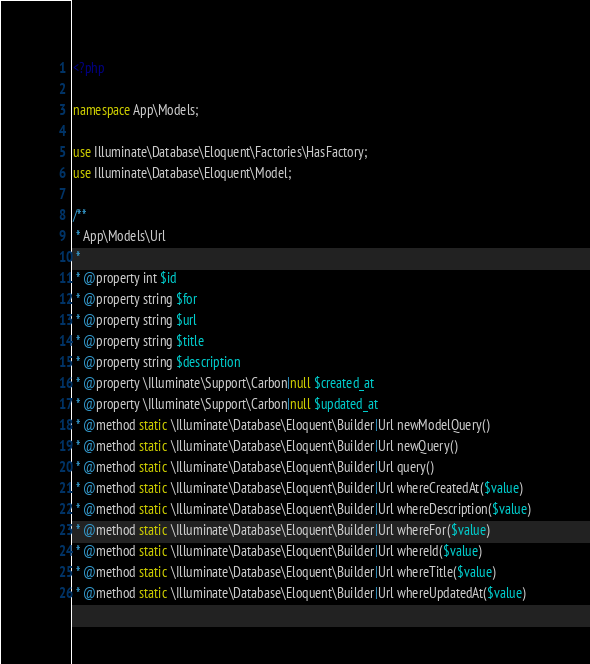Convert code to text. <code><loc_0><loc_0><loc_500><loc_500><_PHP_><?php

namespace App\Models;

use Illuminate\Database\Eloquent\Factories\HasFactory;
use Illuminate\Database\Eloquent\Model;

/**
 * App\Models\Url
 *
 * @property int $id
 * @property string $for
 * @property string $url
 * @property string $title
 * @property string $description
 * @property \Illuminate\Support\Carbon|null $created_at
 * @property \Illuminate\Support\Carbon|null $updated_at
 * @method static \Illuminate\Database\Eloquent\Builder|Url newModelQuery()
 * @method static \Illuminate\Database\Eloquent\Builder|Url newQuery()
 * @method static \Illuminate\Database\Eloquent\Builder|Url query()
 * @method static \Illuminate\Database\Eloquent\Builder|Url whereCreatedAt($value)
 * @method static \Illuminate\Database\Eloquent\Builder|Url whereDescription($value)
 * @method static \Illuminate\Database\Eloquent\Builder|Url whereFor($value)
 * @method static \Illuminate\Database\Eloquent\Builder|Url whereId($value)
 * @method static \Illuminate\Database\Eloquent\Builder|Url whereTitle($value)
 * @method static \Illuminate\Database\Eloquent\Builder|Url whereUpdatedAt($value)</code> 